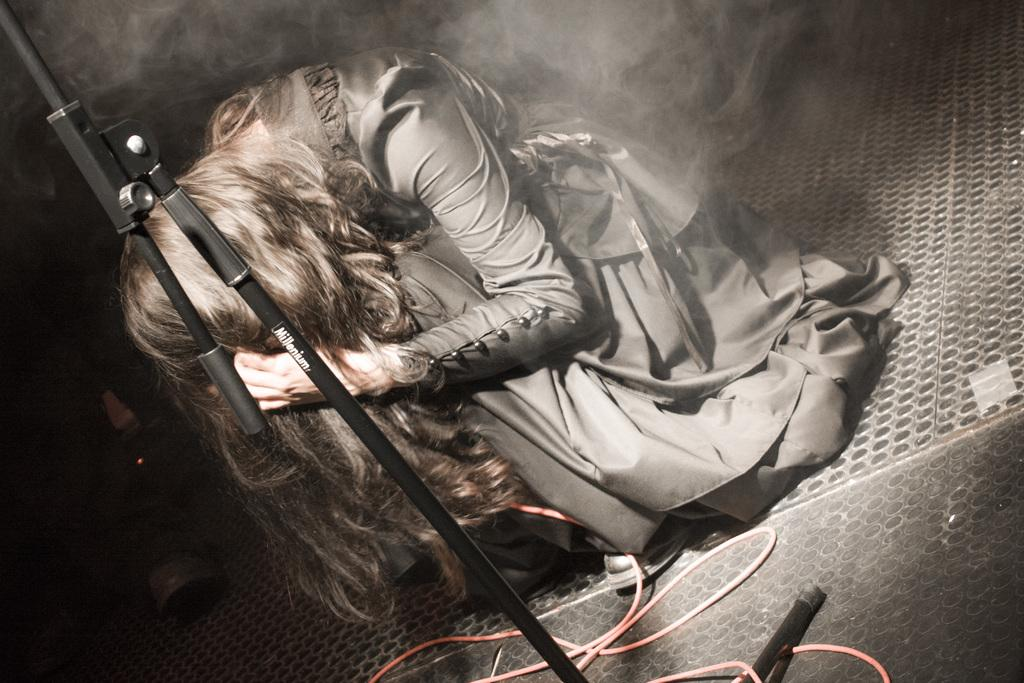What is the girl in the image doing? The girl is sitting on the floor in the image. What is in front of the girl? There is a stand and a wire in front of the girl. Can you describe the background of the image? There is smoke visible in the background of the image. What type of receipt can be seen on the side of the girl in the image? There is no receipt present in the image, and the girl is sitting on the floor, not on the side. 